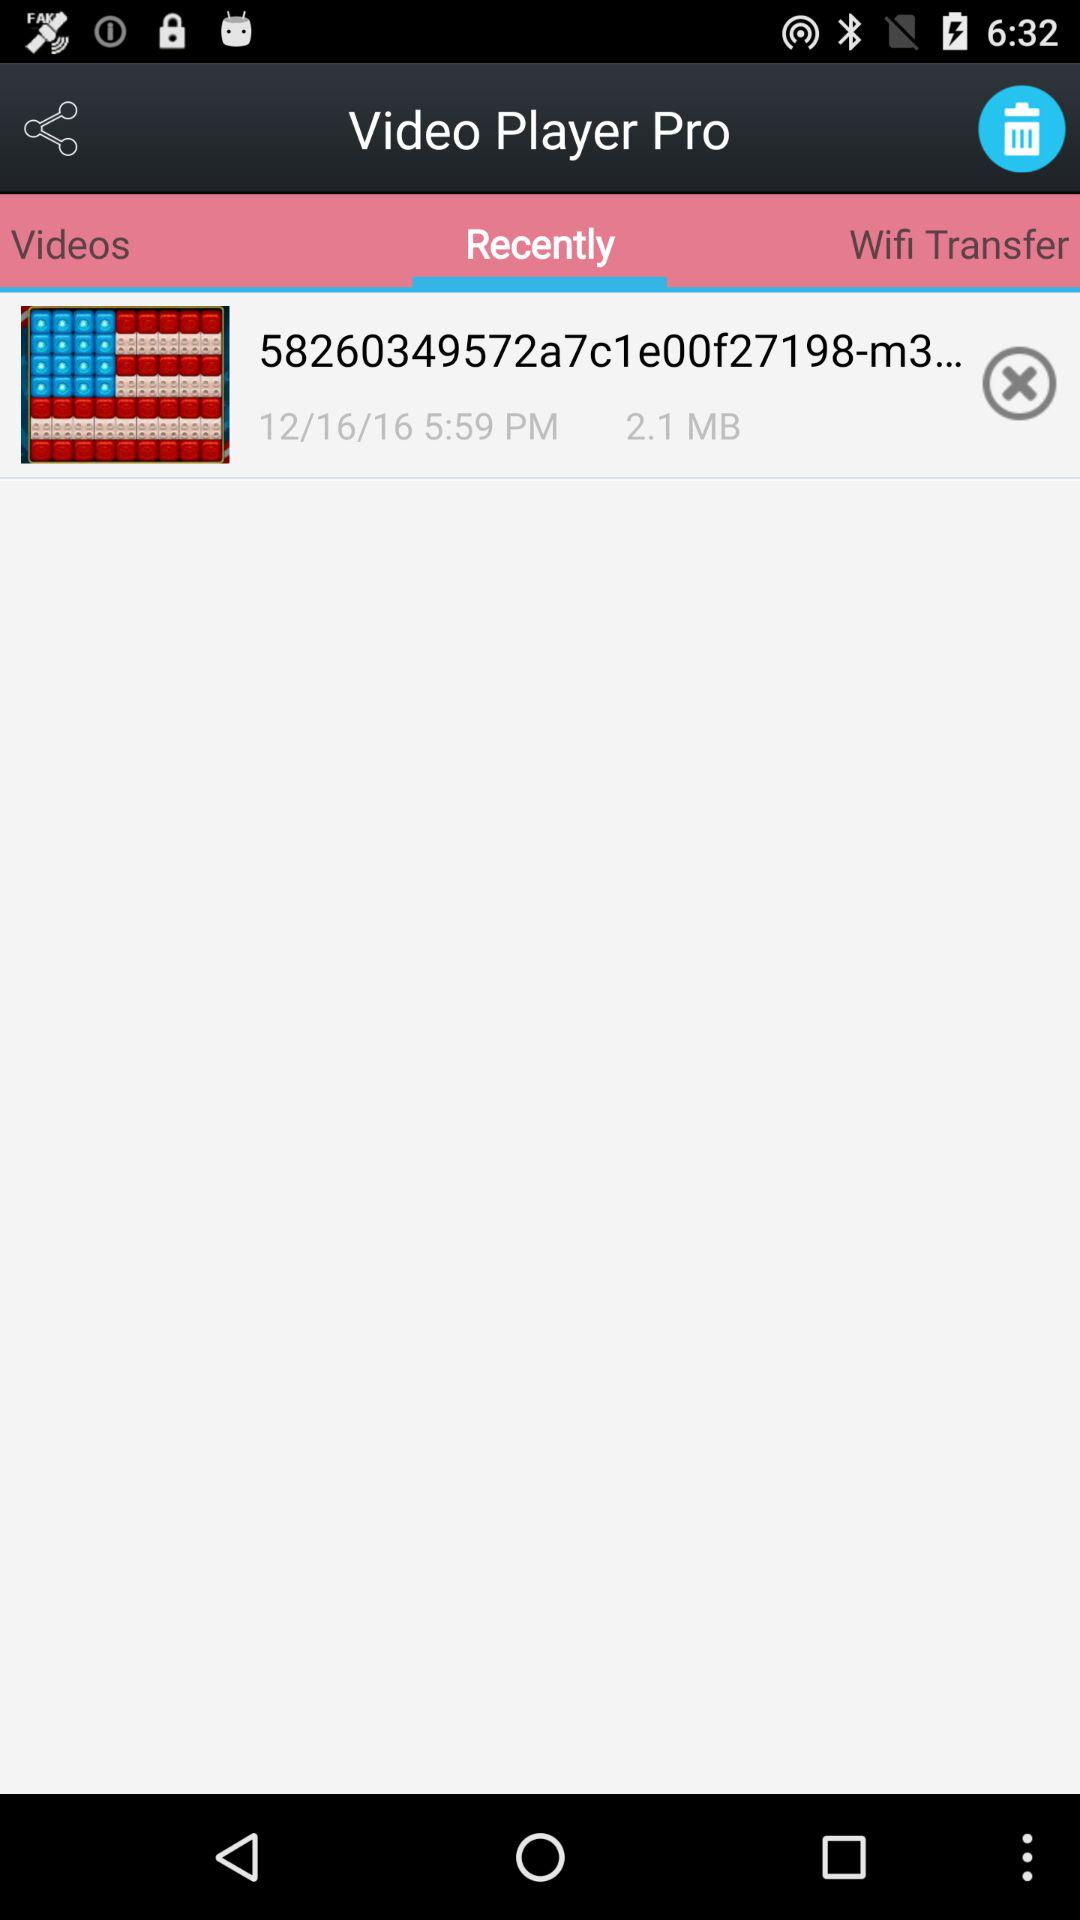What's the name of the video? The name of the video is "58260349572a7c1e00f27198-m3...". 